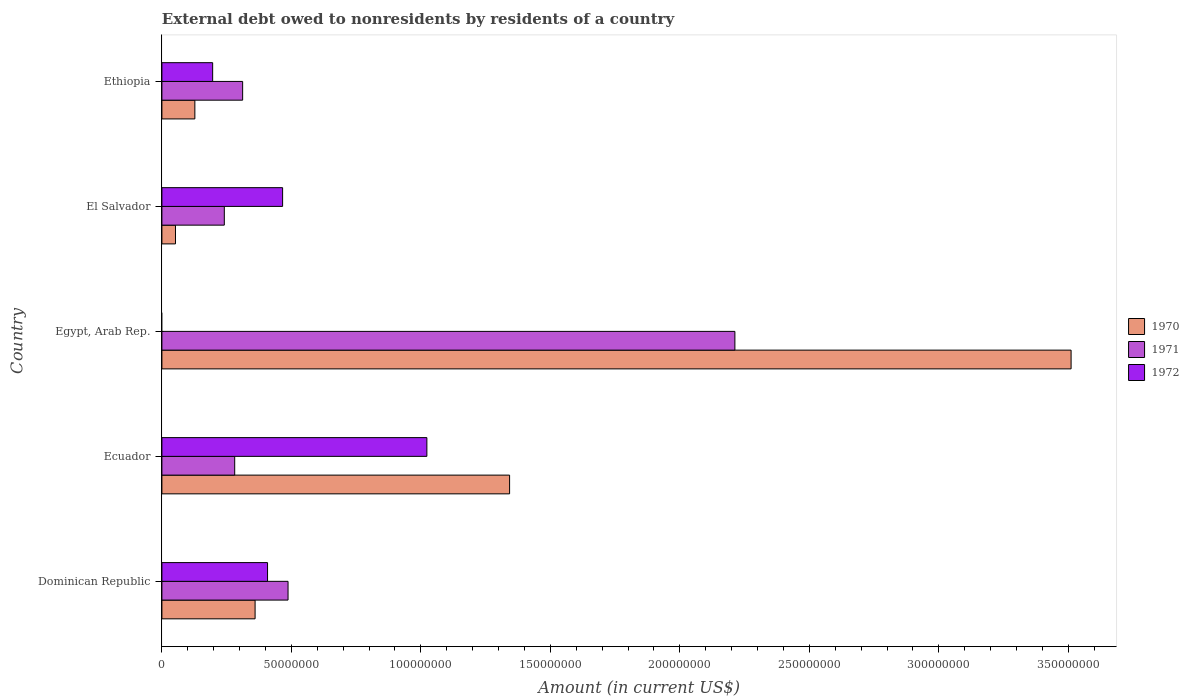How many different coloured bars are there?
Provide a succinct answer. 3. How many bars are there on the 2nd tick from the bottom?
Keep it short and to the point. 3. What is the label of the 1st group of bars from the top?
Provide a succinct answer. Ethiopia. What is the external debt owed by residents in 1971 in Egypt, Arab Rep.?
Provide a succinct answer. 2.21e+08. Across all countries, what is the maximum external debt owed by residents in 1970?
Ensure brevity in your answer.  3.51e+08. Across all countries, what is the minimum external debt owed by residents in 1971?
Keep it short and to the point. 2.41e+07. In which country was the external debt owed by residents in 1972 maximum?
Your answer should be very brief. Ecuador. What is the total external debt owed by residents in 1972 in the graph?
Offer a very short reply. 2.09e+08. What is the difference between the external debt owed by residents in 1970 in Ecuador and that in Ethiopia?
Your answer should be compact. 1.22e+08. What is the difference between the external debt owed by residents in 1971 in Ethiopia and the external debt owed by residents in 1970 in Dominican Republic?
Make the answer very short. -4.81e+06. What is the average external debt owed by residents in 1972 per country?
Offer a very short reply. 4.19e+07. What is the difference between the external debt owed by residents in 1970 and external debt owed by residents in 1972 in Dominican Republic?
Provide a succinct answer. -4.81e+06. What is the ratio of the external debt owed by residents in 1970 in Ecuador to that in Egypt, Arab Rep.?
Your answer should be very brief. 0.38. Is the external debt owed by residents in 1972 in Ecuador less than that in Ethiopia?
Keep it short and to the point. No. What is the difference between the highest and the second highest external debt owed by residents in 1972?
Offer a very short reply. 5.57e+07. What is the difference between the highest and the lowest external debt owed by residents in 1970?
Provide a succinct answer. 3.46e+08. Is the sum of the external debt owed by residents in 1971 in Egypt, Arab Rep. and El Salvador greater than the maximum external debt owed by residents in 1970 across all countries?
Ensure brevity in your answer.  No. Are all the bars in the graph horizontal?
Keep it short and to the point. Yes. What is the difference between two consecutive major ticks on the X-axis?
Give a very brief answer. 5.00e+07. Does the graph contain any zero values?
Your response must be concise. Yes. Where does the legend appear in the graph?
Your response must be concise. Center right. How are the legend labels stacked?
Your answer should be very brief. Vertical. What is the title of the graph?
Your answer should be compact. External debt owed to nonresidents by residents of a country. Does "1966" appear as one of the legend labels in the graph?
Your answer should be very brief. No. What is the label or title of the X-axis?
Provide a short and direct response. Amount (in current US$). What is the Amount (in current US$) in 1970 in Dominican Republic?
Make the answer very short. 3.60e+07. What is the Amount (in current US$) in 1971 in Dominican Republic?
Your answer should be compact. 4.87e+07. What is the Amount (in current US$) in 1972 in Dominican Republic?
Offer a very short reply. 4.08e+07. What is the Amount (in current US$) of 1970 in Ecuador?
Keep it short and to the point. 1.34e+08. What is the Amount (in current US$) in 1971 in Ecuador?
Your response must be concise. 2.81e+07. What is the Amount (in current US$) of 1972 in Ecuador?
Provide a short and direct response. 1.02e+08. What is the Amount (in current US$) in 1970 in Egypt, Arab Rep.?
Ensure brevity in your answer.  3.51e+08. What is the Amount (in current US$) in 1971 in Egypt, Arab Rep.?
Provide a succinct answer. 2.21e+08. What is the Amount (in current US$) in 1970 in El Salvador?
Provide a succinct answer. 5.25e+06. What is the Amount (in current US$) in 1971 in El Salvador?
Provide a succinct answer. 2.41e+07. What is the Amount (in current US$) of 1972 in El Salvador?
Your response must be concise. 4.66e+07. What is the Amount (in current US$) in 1970 in Ethiopia?
Give a very brief answer. 1.27e+07. What is the Amount (in current US$) of 1971 in Ethiopia?
Give a very brief answer. 3.12e+07. What is the Amount (in current US$) of 1972 in Ethiopia?
Provide a short and direct response. 1.96e+07. Across all countries, what is the maximum Amount (in current US$) of 1970?
Provide a short and direct response. 3.51e+08. Across all countries, what is the maximum Amount (in current US$) in 1971?
Your answer should be compact. 2.21e+08. Across all countries, what is the maximum Amount (in current US$) in 1972?
Provide a short and direct response. 1.02e+08. Across all countries, what is the minimum Amount (in current US$) in 1970?
Your answer should be compact. 5.25e+06. Across all countries, what is the minimum Amount (in current US$) of 1971?
Your answer should be compact. 2.41e+07. Across all countries, what is the minimum Amount (in current US$) of 1972?
Provide a short and direct response. 0. What is the total Amount (in current US$) in 1970 in the graph?
Make the answer very short. 5.39e+08. What is the total Amount (in current US$) in 1971 in the graph?
Ensure brevity in your answer.  3.53e+08. What is the total Amount (in current US$) in 1972 in the graph?
Give a very brief answer. 2.09e+08. What is the difference between the Amount (in current US$) in 1970 in Dominican Republic and that in Ecuador?
Your response must be concise. -9.83e+07. What is the difference between the Amount (in current US$) in 1971 in Dominican Republic and that in Ecuador?
Offer a very short reply. 2.06e+07. What is the difference between the Amount (in current US$) in 1972 in Dominican Republic and that in Ecuador?
Provide a short and direct response. -6.15e+07. What is the difference between the Amount (in current US$) of 1970 in Dominican Republic and that in Egypt, Arab Rep.?
Offer a terse response. -3.15e+08. What is the difference between the Amount (in current US$) of 1971 in Dominican Republic and that in Egypt, Arab Rep.?
Your answer should be compact. -1.73e+08. What is the difference between the Amount (in current US$) in 1970 in Dominican Republic and that in El Salvador?
Your answer should be compact. 3.07e+07. What is the difference between the Amount (in current US$) of 1971 in Dominican Republic and that in El Salvador?
Your answer should be very brief. 2.46e+07. What is the difference between the Amount (in current US$) in 1972 in Dominican Republic and that in El Salvador?
Provide a short and direct response. -5.82e+06. What is the difference between the Amount (in current US$) of 1970 in Dominican Republic and that in Ethiopia?
Make the answer very short. 2.33e+07. What is the difference between the Amount (in current US$) of 1971 in Dominican Republic and that in Ethiopia?
Keep it short and to the point. 1.75e+07. What is the difference between the Amount (in current US$) of 1972 in Dominican Republic and that in Ethiopia?
Give a very brief answer. 2.12e+07. What is the difference between the Amount (in current US$) in 1970 in Ecuador and that in Egypt, Arab Rep.?
Ensure brevity in your answer.  -2.17e+08. What is the difference between the Amount (in current US$) in 1971 in Ecuador and that in Egypt, Arab Rep.?
Your answer should be compact. -1.93e+08. What is the difference between the Amount (in current US$) of 1970 in Ecuador and that in El Salvador?
Keep it short and to the point. 1.29e+08. What is the difference between the Amount (in current US$) of 1971 in Ecuador and that in El Salvador?
Make the answer very short. 4.01e+06. What is the difference between the Amount (in current US$) of 1972 in Ecuador and that in El Salvador?
Make the answer very short. 5.57e+07. What is the difference between the Amount (in current US$) in 1970 in Ecuador and that in Ethiopia?
Offer a terse response. 1.22e+08. What is the difference between the Amount (in current US$) in 1971 in Ecuador and that in Ethiopia?
Give a very brief answer. -3.06e+06. What is the difference between the Amount (in current US$) in 1972 in Ecuador and that in Ethiopia?
Your answer should be very brief. 8.27e+07. What is the difference between the Amount (in current US$) in 1970 in Egypt, Arab Rep. and that in El Salvador?
Your response must be concise. 3.46e+08. What is the difference between the Amount (in current US$) of 1971 in Egypt, Arab Rep. and that in El Salvador?
Provide a short and direct response. 1.97e+08. What is the difference between the Amount (in current US$) of 1970 in Egypt, Arab Rep. and that in Ethiopia?
Ensure brevity in your answer.  3.38e+08. What is the difference between the Amount (in current US$) of 1971 in Egypt, Arab Rep. and that in Ethiopia?
Provide a short and direct response. 1.90e+08. What is the difference between the Amount (in current US$) of 1970 in El Salvador and that in Ethiopia?
Provide a short and direct response. -7.48e+06. What is the difference between the Amount (in current US$) in 1971 in El Salvador and that in Ethiopia?
Provide a short and direct response. -7.07e+06. What is the difference between the Amount (in current US$) of 1972 in El Salvador and that in Ethiopia?
Offer a very short reply. 2.70e+07. What is the difference between the Amount (in current US$) in 1970 in Dominican Republic and the Amount (in current US$) in 1971 in Ecuador?
Your response must be concise. 7.88e+06. What is the difference between the Amount (in current US$) of 1970 in Dominican Republic and the Amount (in current US$) of 1972 in Ecuador?
Provide a short and direct response. -6.63e+07. What is the difference between the Amount (in current US$) in 1971 in Dominican Republic and the Amount (in current US$) in 1972 in Ecuador?
Offer a very short reply. -5.36e+07. What is the difference between the Amount (in current US$) of 1970 in Dominican Republic and the Amount (in current US$) of 1971 in Egypt, Arab Rep.?
Keep it short and to the point. -1.85e+08. What is the difference between the Amount (in current US$) in 1970 in Dominican Republic and the Amount (in current US$) in 1971 in El Salvador?
Give a very brief answer. 1.19e+07. What is the difference between the Amount (in current US$) of 1970 in Dominican Republic and the Amount (in current US$) of 1972 in El Salvador?
Give a very brief answer. -1.06e+07. What is the difference between the Amount (in current US$) of 1971 in Dominican Republic and the Amount (in current US$) of 1972 in El Salvador?
Offer a terse response. 2.10e+06. What is the difference between the Amount (in current US$) of 1970 in Dominican Republic and the Amount (in current US$) of 1971 in Ethiopia?
Your answer should be very brief. 4.81e+06. What is the difference between the Amount (in current US$) of 1970 in Dominican Republic and the Amount (in current US$) of 1972 in Ethiopia?
Keep it short and to the point. 1.64e+07. What is the difference between the Amount (in current US$) in 1971 in Dominican Republic and the Amount (in current US$) in 1972 in Ethiopia?
Provide a short and direct response. 2.91e+07. What is the difference between the Amount (in current US$) of 1970 in Ecuador and the Amount (in current US$) of 1971 in Egypt, Arab Rep.?
Keep it short and to the point. -8.70e+07. What is the difference between the Amount (in current US$) of 1970 in Ecuador and the Amount (in current US$) of 1971 in El Salvador?
Give a very brief answer. 1.10e+08. What is the difference between the Amount (in current US$) of 1970 in Ecuador and the Amount (in current US$) of 1972 in El Salvador?
Give a very brief answer. 8.76e+07. What is the difference between the Amount (in current US$) in 1971 in Ecuador and the Amount (in current US$) in 1972 in El Salvador?
Offer a terse response. -1.85e+07. What is the difference between the Amount (in current US$) in 1970 in Ecuador and the Amount (in current US$) in 1971 in Ethiopia?
Ensure brevity in your answer.  1.03e+08. What is the difference between the Amount (in current US$) of 1970 in Ecuador and the Amount (in current US$) of 1972 in Ethiopia?
Your answer should be very brief. 1.15e+08. What is the difference between the Amount (in current US$) of 1971 in Ecuador and the Amount (in current US$) of 1972 in Ethiopia?
Provide a short and direct response. 8.52e+06. What is the difference between the Amount (in current US$) of 1970 in Egypt, Arab Rep. and the Amount (in current US$) of 1971 in El Salvador?
Your response must be concise. 3.27e+08. What is the difference between the Amount (in current US$) of 1970 in Egypt, Arab Rep. and the Amount (in current US$) of 1972 in El Salvador?
Give a very brief answer. 3.04e+08. What is the difference between the Amount (in current US$) of 1971 in Egypt, Arab Rep. and the Amount (in current US$) of 1972 in El Salvador?
Your answer should be compact. 1.75e+08. What is the difference between the Amount (in current US$) in 1970 in Egypt, Arab Rep. and the Amount (in current US$) in 1971 in Ethiopia?
Provide a short and direct response. 3.20e+08. What is the difference between the Amount (in current US$) in 1970 in Egypt, Arab Rep. and the Amount (in current US$) in 1972 in Ethiopia?
Your response must be concise. 3.31e+08. What is the difference between the Amount (in current US$) in 1971 in Egypt, Arab Rep. and the Amount (in current US$) in 1972 in Ethiopia?
Offer a terse response. 2.02e+08. What is the difference between the Amount (in current US$) in 1970 in El Salvador and the Amount (in current US$) in 1971 in Ethiopia?
Provide a succinct answer. -2.59e+07. What is the difference between the Amount (in current US$) in 1970 in El Salvador and the Amount (in current US$) in 1972 in Ethiopia?
Offer a terse response. -1.44e+07. What is the difference between the Amount (in current US$) of 1971 in El Salvador and the Amount (in current US$) of 1972 in Ethiopia?
Offer a terse response. 4.50e+06. What is the average Amount (in current US$) of 1970 per country?
Ensure brevity in your answer.  1.08e+08. What is the average Amount (in current US$) of 1971 per country?
Keep it short and to the point. 7.07e+07. What is the average Amount (in current US$) in 1972 per country?
Provide a succinct answer. 4.19e+07. What is the difference between the Amount (in current US$) in 1970 and Amount (in current US$) in 1971 in Dominican Republic?
Your answer should be very brief. -1.27e+07. What is the difference between the Amount (in current US$) of 1970 and Amount (in current US$) of 1972 in Dominican Republic?
Keep it short and to the point. -4.81e+06. What is the difference between the Amount (in current US$) in 1971 and Amount (in current US$) in 1972 in Dominican Republic?
Give a very brief answer. 7.91e+06. What is the difference between the Amount (in current US$) in 1970 and Amount (in current US$) in 1971 in Ecuador?
Provide a short and direct response. 1.06e+08. What is the difference between the Amount (in current US$) in 1970 and Amount (in current US$) in 1972 in Ecuador?
Your answer should be very brief. 3.19e+07. What is the difference between the Amount (in current US$) of 1971 and Amount (in current US$) of 1972 in Ecuador?
Your answer should be compact. -7.42e+07. What is the difference between the Amount (in current US$) in 1970 and Amount (in current US$) in 1971 in Egypt, Arab Rep.?
Give a very brief answer. 1.30e+08. What is the difference between the Amount (in current US$) in 1970 and Amount (in current US$) in 1971 in El Salvador?
Offer a terse response. -1.89e+07. What is the difference between the Amount (in current US$) of 1970 and Amount (in current US$) of 1972 in El Salvador?
Your answer should be compact. -4.14e+07. What is the difference between the Amount (in current US$) of 1971 and Amount (in current US$) of 1972 in El Salvador?
Provide a short and direct response. -2.25e+07. What is the difference between the Amount (in current US$) of 1970 and Amount (in current US$) of 1971 in Ethiopia?
Provide a short and direct response. -1.84e+07. What is the difference between the Amount (in current US$) in 1970 and Amount (in current US$) in 1972 in Ethiopia?
Make the answer very short. -6.87e+06. What is the difference between the Amount (in current US$) in 1971 and Amount (in current US$) in 1972 in Ethiopia?
Keep it short and to the point. 1.16e+07. What is the ratio of the Amount (in current US$) in 1970 in Dominican Republic to that in Ecuador?
Ensure brevity in your answer.  0.27. What is the ratio of the Amount (in current US$) in 1971 in Dominican Republic to that in Ecuador?
Ensure brevity in your answer.  1.73. What is the ratio of the Amount (in current US$) in 1972 in Dominican Republic to that in Ecuador?
Give a very brief answer. 0.4. What is the ratio of the Amount (in current US$) in 1970 in Dominican Republic to that in Egypt, Arab Rep.?
Provide a short and direct response. 0.1. What is the ratio of the Amount (in current US$) in 1971 in Dominican Republic to that in Egypt, Arab Rep.?
Your answer should be very brief. 0.22. What is the ratio of the Amount (in current US$) of 1970 in Dominican Republic to that in El Salvador?
Offer a very short reply. 6.86. What is the ratio of the Amount (in current US$) in 1971 in Dominican Republic to that in El Salvador?
Give a very brief answer. 2.02. What is the ratio of the Amount (in current US$) in 1972 in Dominican Republic to that in El Salvador?
Your answer should be very brief. 0.88. What is the ratio of the Amount (in current US$) of 1970 in Dominican Republic to that in Ethiopia?
Your answer should be very brief. 2.83. What is the ratio of the Amount (in current US$) in 1971 in Dominican Republic to that in Ethiopia?
Your answer should be very brief. 1.56. What is the ratio of the Amount (in current US$) in 1972 in Dominican Republic to that in Ethiopia?
Your answer should be compact. 2.08. What is the ratio of the Amount (in current US$) of 1970 in Ecuador to that in Egypt, Arab Rep.?
Provide a succinct answer. 0.38. What is the ratio of the Amount (in current US$) in 1971 in Ecuador to that in Egypt, Arab Rep.?
Your answer should be compact. 0.13. What is the ratio of the Amount (in current US$) in 1970 in Ecuador to that in El Salvador?
Make the answer very short. 25.59. What is the ratio of the Amount (in current US$) of 1971 in Ecuador to that in El Salvador?
Offer a very short reply. 1.17. What is the ratio of the Amount (in current US$) of 1972 in Ecuador to that in El Salvador?
Your answer should be very brief. 2.2. What is the ratio of the Amount (in current US$) in 1970 in Ecuador to that in Ethiopia?
Your answer should be very brief. 10.55. What is the ratio of the Amount (in current US$) in 1971 in Ecuador to that in Ethiopia?
Your response must be concise. 0.9. What is the ratio of the Amount (in current US$) of 1972 in Ecuador to that in Ethiopia?
Keep it short and to the point. 5.22. What is the ratio of the Amount (in current US$) of 1970 in Egypt, Arab Rep. to that in El Salvador?
Your answer should be very brief. 66.92. What is the ratio of the Amount (in current US$) in 1971 in Egypt, Arab Rep. to that in El Salvador?
Your answer should be compact. 9.18. What is the ratio of the Amount (in current US$) of 1970 in Egypt, Arab Rep. to that in Ethiopia?
Keep it short and to the point. 27.59. What is the ratio of the Amount (in current US$) in 1971 in Egypt, Arab Rep. to that in Ethiopia?
Provide a succinct answer. 7.1. What is the ratio of the Amount (in current US$) in 1970 in El Salvador to that in Ethiopia?
Give a very brief answer. 0.41. What is the ratio of the Amount (in current US$) in 1971 in El Salvador to that in Ethiopia?
Make the answer very short. 0.77. What is the ratio of the Amount (in current US$) in 1972 in El Salvador to that in Ethiopia?
Make the answer very short. 2.38. What is the difference between the highest and the second highest Amount (in current US$) of 1970?
Offer a very short reply. 2.17e+08. What is the difference between the highest and the second highest Amount (in current US$) in 1971?
Offer a very short reply. 1.73e+08. What is the difference between the highest and the second highest Amount (in current US$) of 1972?
Your answer should be very brief. 5.57e+07. What is the difference between the highest and the lowest Amount (in current US$) in 1970?
Provide a succinct answer. 3.46e+08. What is the difference between the highest and the lowest Amount (in current US$) in 1971?
Give a very brief answer. 1.97e+08. What is the difference between the highest and the lowest Amount (in current US$) of 1972?
Your response must be concise. 1.02e+08. 